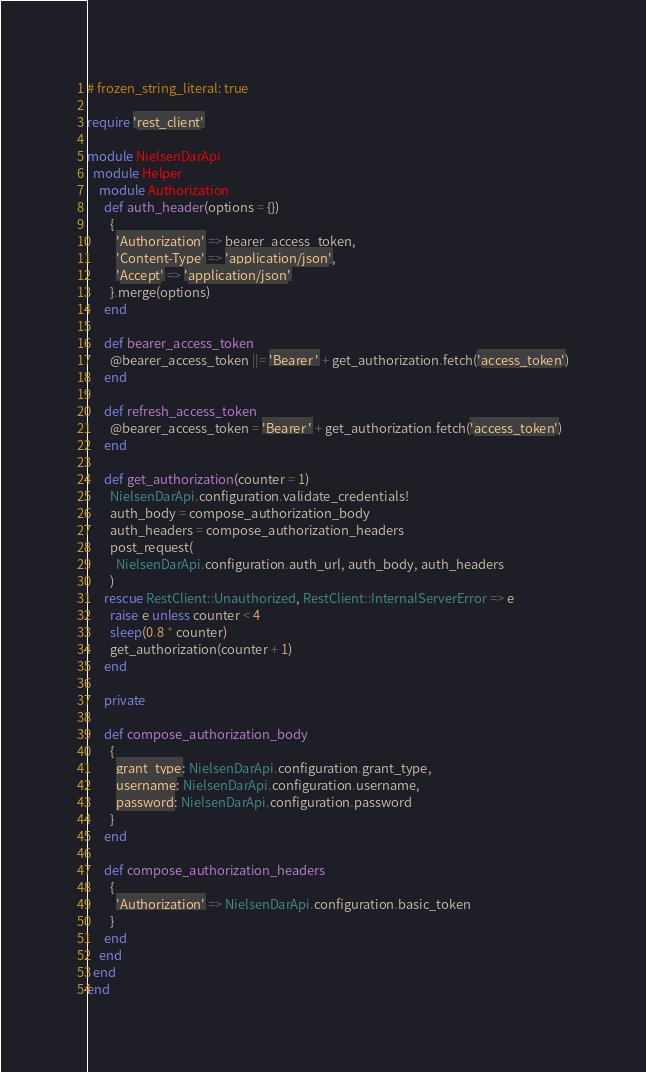<code> <loc_0><loc_0><loc_500><loc_500><_Ruby_># frozen_string_literal: true

require 'rest_client'

module NielsenDarApi
  module Helper
    module Authorization
      def auth_header(options = {})
        {
          'Authorization' => bearer_access_token,
          'Content-Type' => 'application/json',
          'Accept' => 'application/json'
        }.merge(options)
      end

      def bearer_access_token
        @bearer_access_token ||= 'Bearer ' + get_authorization.fetch('access_token')
      end

      def refresh_access_token
        @bearer_access_token = 'Bearer ' + get_authorization.fetch('access_token')
      end

      def get_authorization(counter = 1)
        NielsenDarApi.configuration.validate_credentials!
        auth_body = compose_authorization_body
        auth_headers = compose_authorization_headers
        post_request(
          NielsenDarApi.configuration.auth_url, auth_body, auth_headers
        )
      rescue RestClient::Unauthorized, RestClient::InternalServerError => e
        raise e unless counter < 4
        sleep(0.8 * counter)
        get_authorization(counter + 1)
      end

      private

      def compose_authorization_body
        {
          grant_type: NielsenDarApi.configuration.grant_type,
          username: NielsenDarApi.configuration.username,
          password: NielsenDarApi.configuration.password
        }
      end

      def compose_authorization_headers
        {
          'Authorization' => NielsenDarApi.configuration.basic_token
        }
      end
    end
  end
end
</code> 